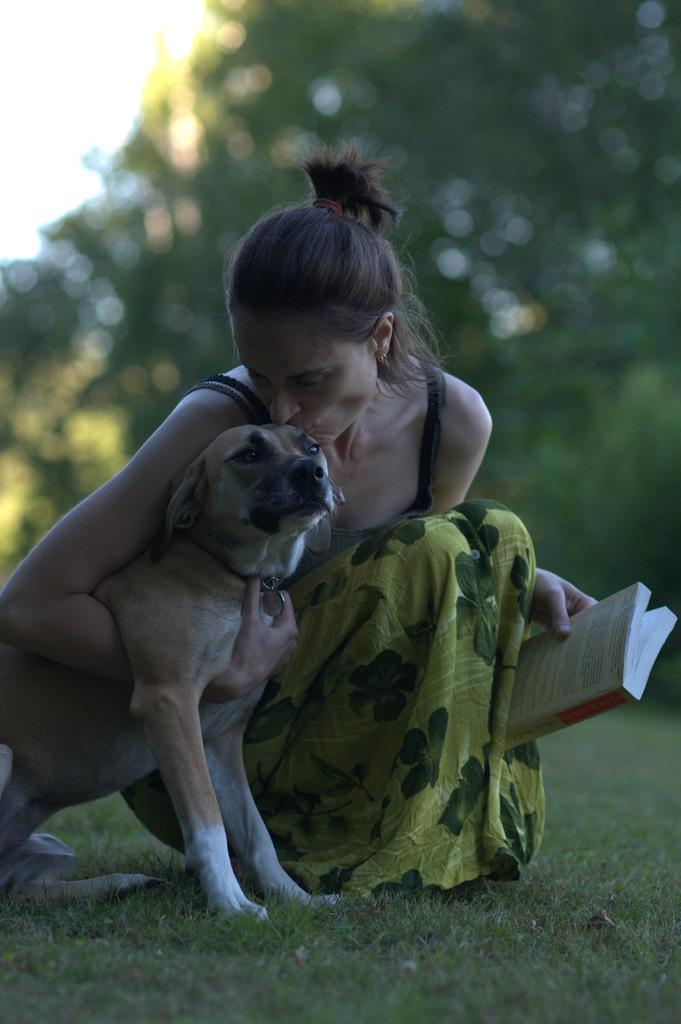Who is present in the image? There is a woman in the image. What is the woman holding? The woman is holding a book. What animal is beside the woman? There is a dog beside the woman. What type of terrain is visible at the bottom of the image? Grass is visible at the bottom of the image. What can be seen in the distance in the image? There are trees in the background of the image. What type of basket is visible in the woman's vein in the image? There is no basket or reference to veins in the image; it features a woman holding a book, a dog, grass, and trees in the background. 